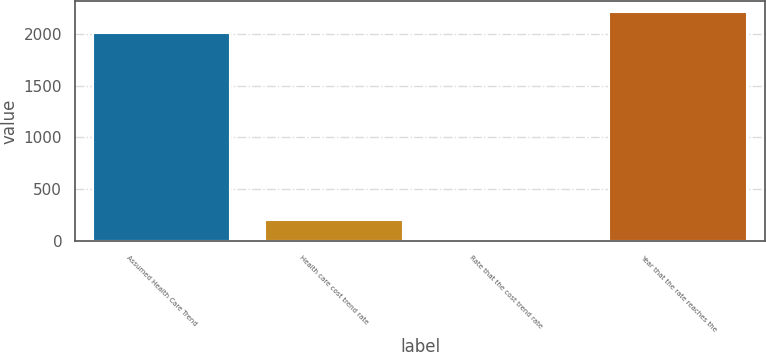<chart> <loc_0><loc_0><loc_500><loc_500><bar_chart><fcel>Assumed Health Care Trend<fcel>Health care cost trend rate<fcel>Rate that the cost trend rate<fcel>Year that the rate reaches the<nl><fcel>2008<fcel>205.8<fcel>5<fcel>2208.8<nl></chart> 